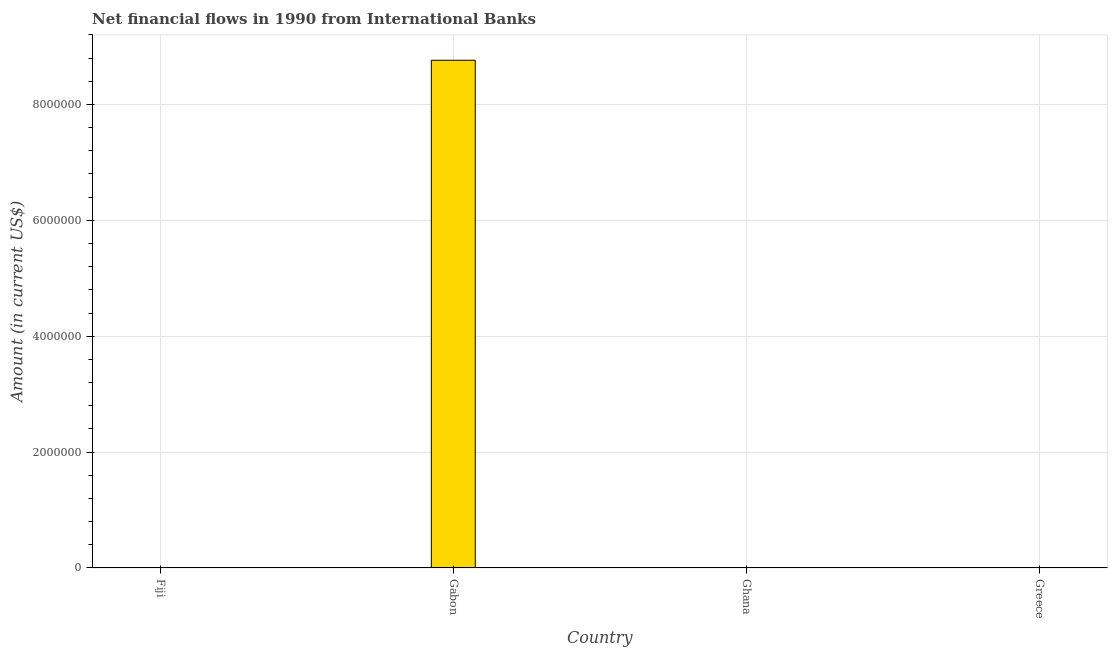Does the graph contain any zero values?
Ensure brevity in your answer.  Yes. What is the title of the graph?
Provide a short and direct response. Net financial flows in 1990 from International Banks. What is the label or title of the X-axis?
Provide a short and direct response. Country. What is the net financial flows from ibrd in Greece?
Offer a very short reply. 0. Across all countries, what is the maximum net financial flows from ibrd?
Offer a very short reply. 8.76e+06. In which country was the net financial flows from ibrd maximum?
Provide a short and direct response. Gabon. What is the sum of the net financial flows from ibrd?
Give a very brief answer. 8.76e+06. What is the average net financial flows from ibrd per country?
Provide a short and direct response. 2.19e+06. What is the difference between the highest and the lowest net financial flows from ibrd?
Offer a very short reply. 8.76e+06. What is the Amount (in current US$) of Fiji?
Offer a terse response. 0. What is the Amount (in current US$) of Gabon?
Make the answer very short. 8.76e+06. What is the Amount (in current US$) in Ghana?
Your answer should be very brief. 0. What is the Amount (in current US$) in Greece?
Provide a short and direct response. 0. 